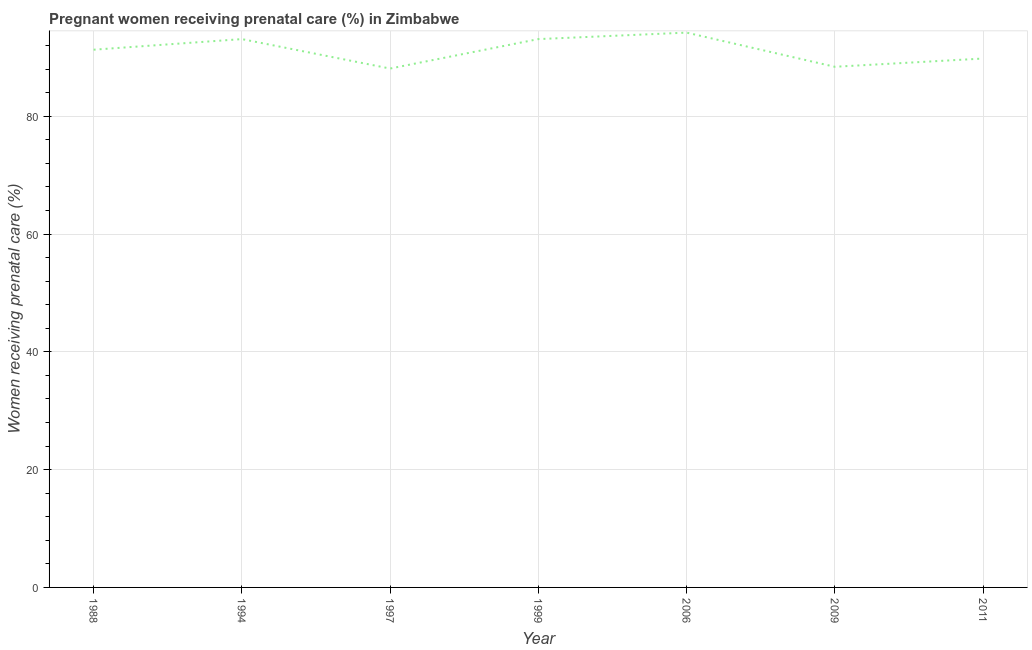What is the percentage of pregnant women receiving prenatal care in 2006?
Your answer should be very brief. 94.2. Across all years, what is the maximum percentage of pregnant women receiving prenatal care?
Ensure brevity in your answer.  94.2. Across all years, what is the minimum percentage of pregnant women receiving prenatal care?
Offer a terse response. 88.1. In which year was the percentage of pregnant women receiving prenatal care maximum?
Provide a succinct answer. 2006. What is the sum of the percentage of pregnant women receiving prenatal care?
Your answer should be compact. 638. What is the difference between the percentage of pregnant women receiving prenatal care in 1988 and 1999?
Make the answer very short. -1.8. What is the average percentage of pregnant women receiving prenatal care per year?
Offer a terse response. 91.14. What is the median percentage of pregnant women receiving prenatal care?
Offer a terse response. 91.3. In how many years, is the percentage of pregnant women receiving prenatal care greater than 68 %?
Give a very brief answer. 7. What is the ratio of the percentage of pregnant women receiving prenatal care in 1999 to that in 2011?
Give a very brief answer. 1.04. Is the percentage of pregnant women receiving prenatal care in 1994 less than that in 1997?
Keep it short and to the point. No. Is the difference between the percentage of pregnant women receiving prenatal care in 2009 and 2011 greater than the difference between any two years?
Offer a terse response. No. What is the difference between the highest and the second highest percentage of pregnant women receiving prenatal care?
Offer a very short reply. 1.1. What is the difference between the highest and the lowest percentage of pregnant women receiving prenatal care?
Provide a short and direct response. 6.1. Are the values on the major ticks of Y-axis written in scientific E-notation?
Provide a succinct answer. No. Does the graph contain grids?
Give a very brief answer. Yes. What is the title of the graph?
Keep it short and to the point. Pregnant women receiving prenatal care (%) in Zimbabwe. What is the label or title of the X-axis?
Your answer should be very brief. Year. What is the label or title of the Y-axis?
Make the answer very short. Women receiving prenatal care (%). What is the Women receiving prenatal care (%) in 1988?
Keep it short and to the point. 91.3. What is the Women receiving prenatal care (%) of 1994?
Your answer should be compact. 93.1. What is the Women receiving prenatal care (%) of 1997?
Your answer should be compact. 88.1. What is the Women receiving prenatal care (%) in 1999?
Provide a short and direct response. 93.1. What is the Women receiving prenatal care (%) in 2006?
Offer a very short reply. 94.2. What is the Women receiving prenatal care (%) in 2009?
Ensure brevity in your answer.  88.4. What is the Women receiving prenatal care (%) in 2011?
Provide a succinct answer. 89.8. What is the difference between the Women receiving prenatal care (%) in 1988 and 1994?
Provide a short and direct response. -1.8. What is the difference between the Women receiving prenatal care (%) in 1988 and 2006?
Offer a very short reply. -2.9. What is the difference between the Women receiving prenatal care (%) in 1988 and 2009?
Ensure brevity in your answer.  2.9. What is the difference between the Women receiving prenatal care (%) in 1988 and 2011?
Give a very brief answer. 1.5. What is the difference between the Women receiving prenatal care (%) in 1994 and 1997?
Keep it short and to the point. 5. What is the difference between the Women receiving prenatal care (%) in 1994 and 1999?
Provide a succinct answer. 0. What is the difference between the Women receiving prenatal care (%) in 1994 and 2006?
Offer a very short reply. -1.1. What is the difference between the Women receiving prenatal care (%) in 1994 and 2009?
Make the answer very short. 4.7. What is the difference between the Women receiving prenatal care (%) in 1997 and 2011?
Give a very brief answer. -1.7. What is the difference between the Women receiving prenatal care (%) in 1999 and 2009?
Your response must be concise. 4.7. What is the difference between the Women receiving prenatal care (%) in 1999 and 2011?
Provide a succinct answer. 3.3. What is the difference between the Women receiving prenatal care (%) in 2009 and 2011?
Your answer should be compact. -1.4. What is the ratio of the Women receiving prenatal care (%) in 1988 to that in 1997?
Make the answer very short. 1.04. What is the ratio of the Women receiving prenatal care (%) in 1988 to that in 2006?
Your answer should be very brief. 0.97. What is the ratio of the Women receiving prenatal care (%) in 1988 to that in 2009?
Keep it short and to the point. 1.03. What is the ratio of the Women receiving prenatal care (%) in 1988 to that in 2011?
Offer a very short reply. 1.02. What is the ratio of the Women receiving prenatal care (%) in 1994 to that in 1997?
Offer a very short reply. 1.06. What is the ratio of the Women receiving prenatal care (%) in 1994 to that in 2009?
Give a very brief answer. 1.05. What is the ratio of the Women receiving prenatal care (%) in 1994 to that in 2011?
Ensure brevity in your answer.  1.04. What is the ratio of the Women receiving prenatal care (%) in 1997 to that in 1999?
Make the answer very short. 0.95. What is the ratio of the Women receiving prenatal care (%) in 1997 to that in 2006?
Give a very brief answer. 0.94. What is the ratio of the Women receiving prenatal care (%) in 1997 to that in 2009?
Provide a short and direct response. 1. What is the ratio of the Women receiving prenatal care (%) in 1999 to that in 2009?
Your response must be concise. 1.05. What is the ratio of the Women receiving prenatal care (%) in 2006 to that in 2009?
Provide a short and direct response. 1.07. What is the ratio of the Women receiving prenatal care (%) in 2006 to that in 2011?
Your answer should be compact. 1.05. What is the ratio of the Women receiving prenatal care (%) in 2009 to that in 2011?
Keep it short and to the point. 0.98. 